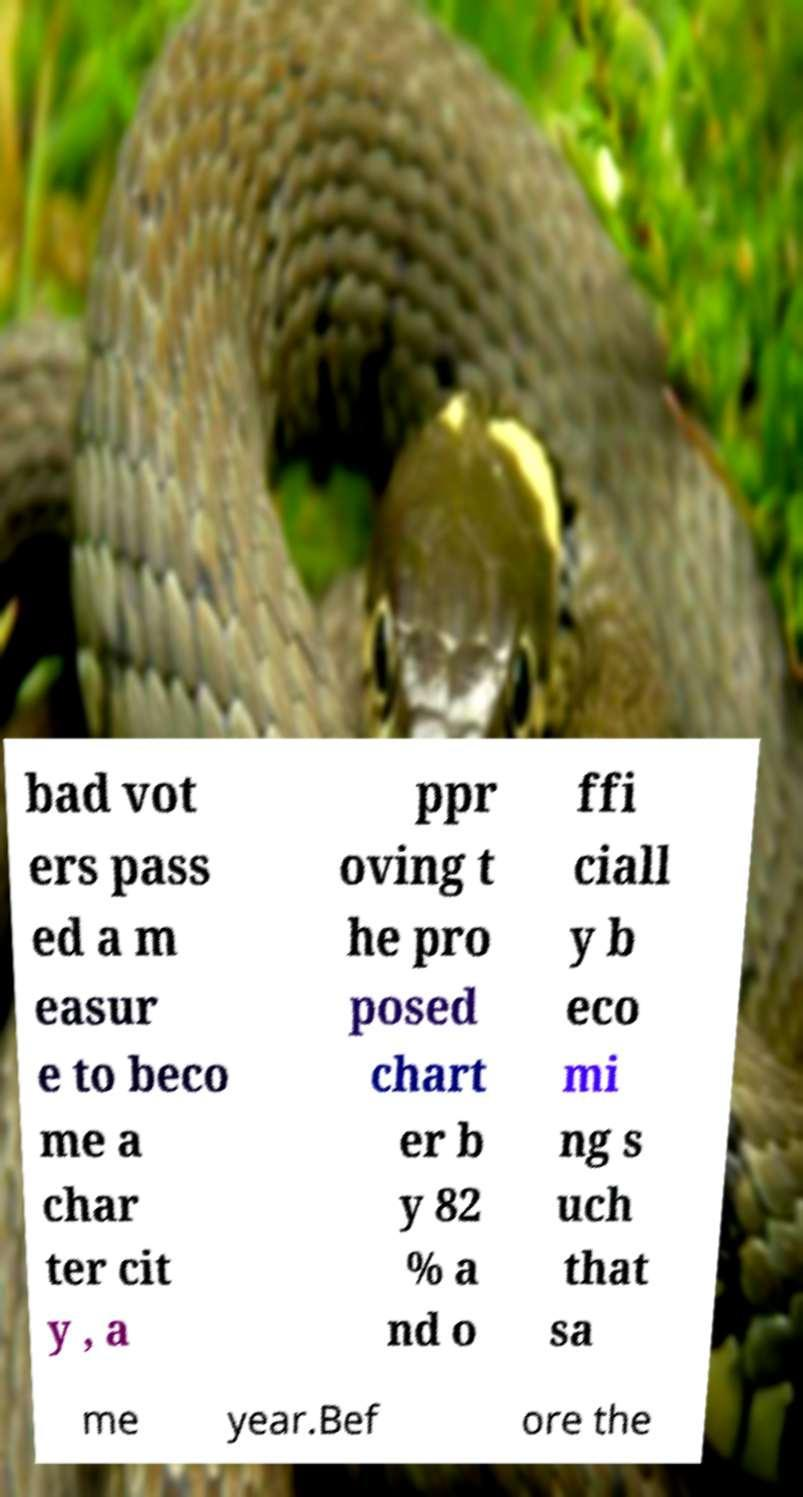Could you assist in decoding the text presented in this image and type it out clearly? bad vot ers pass ed a m easur e to beco me a char ter cit y , a ppr oving t he pro posed chart er b y 82 % a nd o ffi ciall y b eco mi ng s uch that sa me year.Bef ore the 